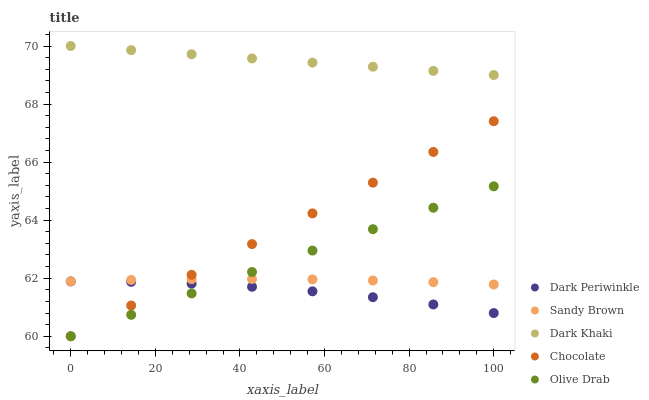Does Dark Periwinkle have the minimum area under the curve?
Answer yes or no. Yes. Does Dark Khaki have the maximum area under the curve?
Answer yes or no. Yes. Does Sandy Brown have the minimum area under the curve?
Answer yes or no. No. Does Sandy Brown have the maximum area under the curve?
Answer yes or no. No. Is Dark Khaki the smoothest?
Answer yes or no. Yes. Is Dark Periwinkle the roughest?
Answer yes or no. Yes. Is Sandy Brown the smoothest?
Answer yes or no. No. Is Sandy Brown the roughest?
Answer yes or no. No. Does Olive Drab have the lowest value?
Answer yes or no. Yes. Does Sandy Brown have the lowest value?
Answer yes or no. No. Does Dark Khaki have the highest value?
Answer yes or no. Yes. Does Sandy Brown have the highest value?
Answer yes or no. No. Is Dark Periwinkle less than Sandy Brown?
Answer yes or no. Yes. Is Dark Khaki greater than Dark Periwinkle?
Answer yes or no. Yes. Does Sandy Brown intersect Chocolate?
Answer yes or no. Yes. Is Sandy Brown less than Chocolate?
Answer yes or no. No. Is Sandy Brown greater than Chocolate?
Answer yes or no. No. Does Dark Periwinkle intersect Sandy Brown?
Answer yes or no. No. 